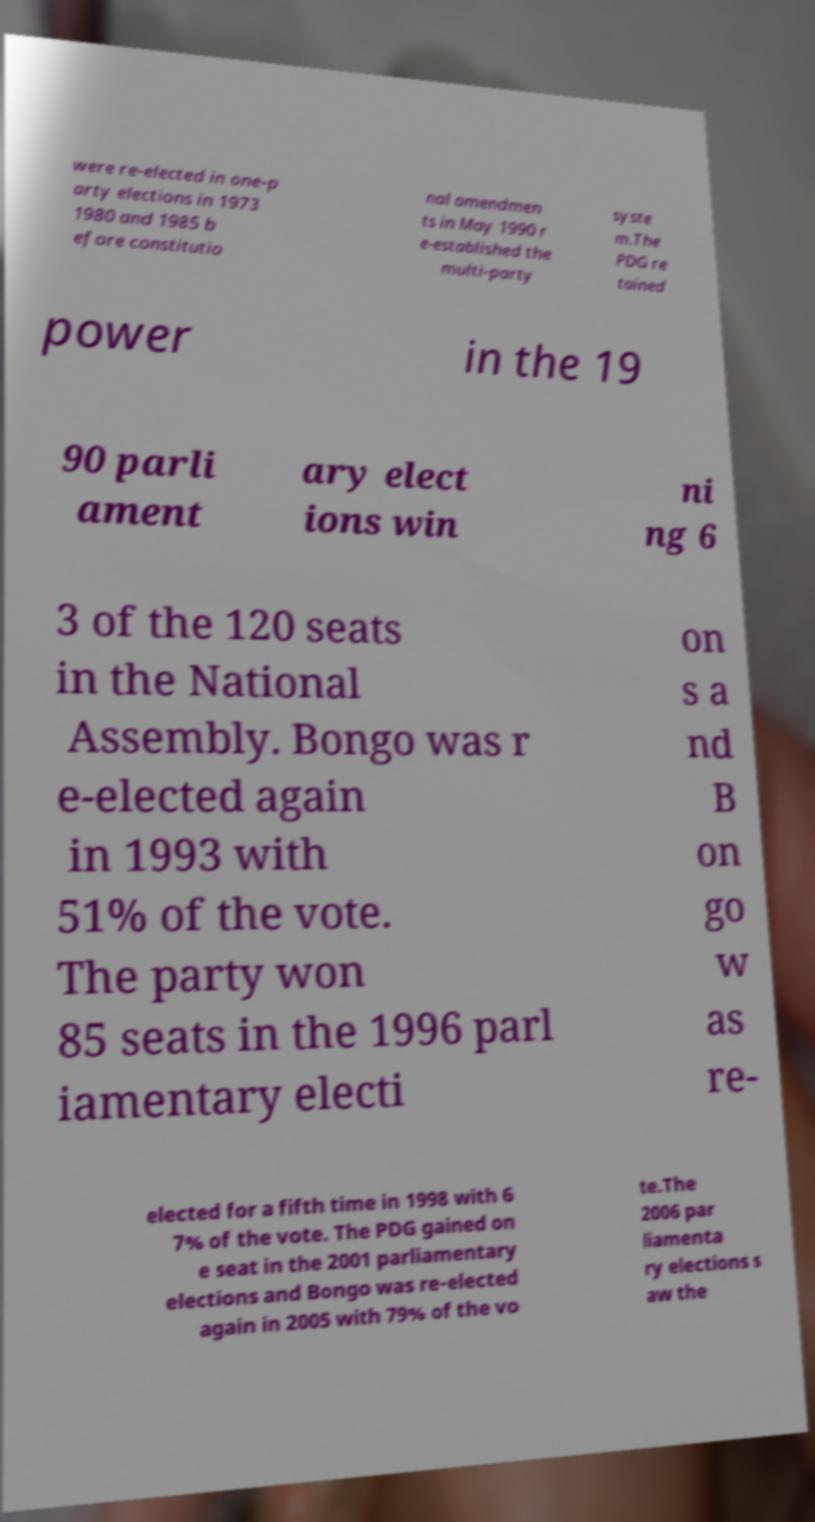What messages or text are displayed in this image? I need them in a readable, typed format. were re-elected in one-p arty elections in 1973 1980 and 1985 b efore constitutio nal amendmen ts in May 1990 r e-established the multi-party syste m.The PDG re tained power in the 19 90 parli ament ary elect ions win ni ng 6 3 of the 120 seats in the National Assembly. Bongo was r e-elected again in 1993 with 51% of the vote. The party won 85 seats in the 1996 parl iamentary electi on s a nd B on go w as re- elected for a fifth time in 1998 with 6 7% of the vote. The PDG gained on e seat in the 2001 parliamentary elections and Bongo was re-elected again in 2005 with 79% of the vo te.The 2006 par liamenta ry elections s aw the 